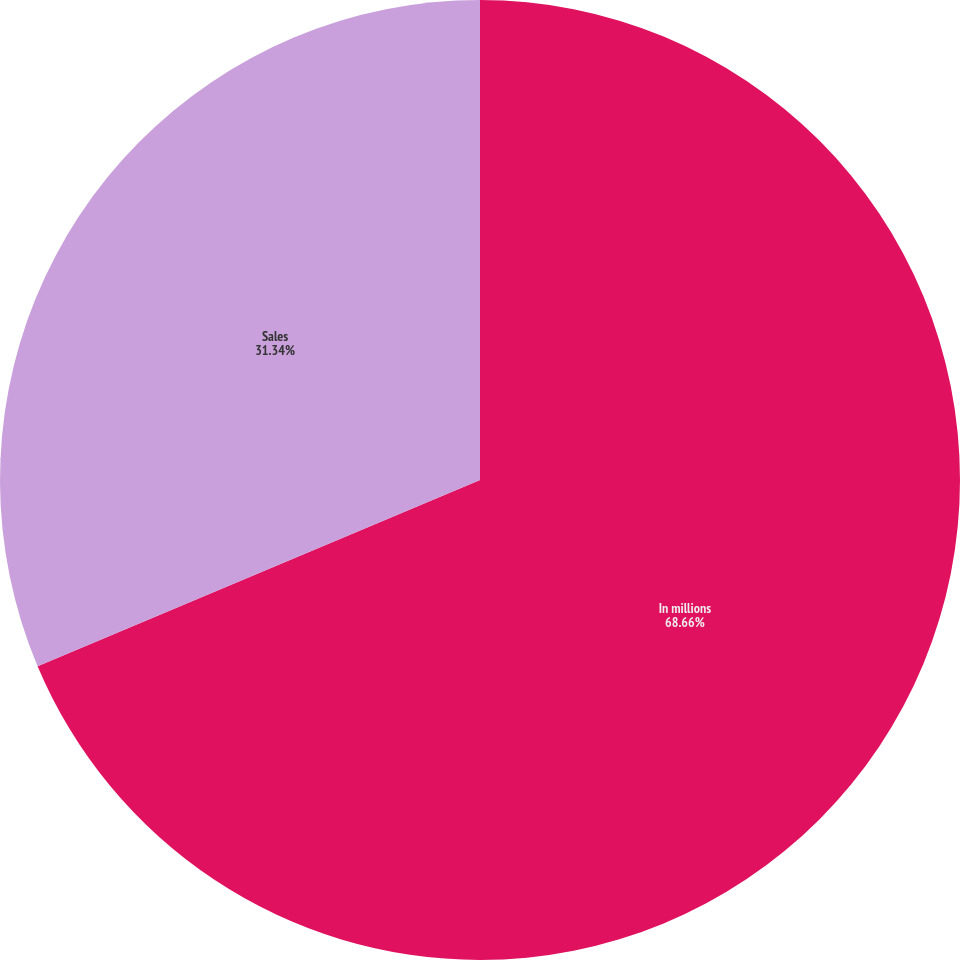Convert chart. <chart><loc_0><loc_0><loc_500><loc_500><pie_chart><fcel>In millions<fcel>Sales<nl><fcel>68.66%<fcel>31.34%<nl></chart> 